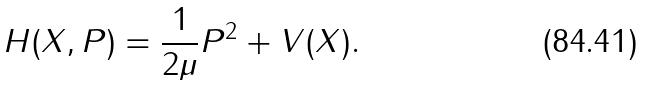Convert formula to latex. <formula><loc_0><loc_0><loc_500><loc_500>H ( X , P ) = \frac { 1 } { 2 \mu } P ^ { 2 } + V ( X ) .</formula> 